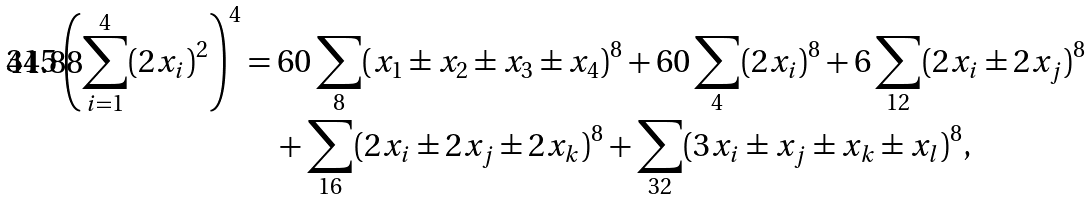Convert formula to latex. <formula><loc_0><loc_0><loc_500><loc_500>3 1 5 \left ( \sum _ { i = 1 } ^ { 4 } ( 2 x _ { i } ) ^ { 2 } \right ) ^ { 4 } & = 6 0 \sum _ { 8 } ( x _ { 1 } \pm x _ { 2 } \pm x _ { 3 } \pm x _ { 4 } ) ^ { 8 } + 6 0 \sum _ { 4 } ( 2 x _ { i } ) ^ { 8 } + 6 \sum _ { 1 2 } ( 2 x _ { i } \pm 2 x _ { j } ) ^ { 8 } \\ & \quad + \sum _ { 1 6 } ( 2 x _ { i } \pm 2 x _ { j } \pm 2 x _ { k } ) ^ { 8 } + \sum _ { 3 2 } ( 3 x _ { i } \pm x _ { j } \pm x _ { k } \pm x _ { l } ) ^ { 8 } ,</formula> 